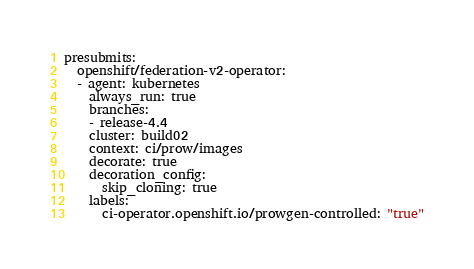<code> <loc_0><loc_0><loc_500><loc_500><_YAML_>presubmits:
  openshift/federation-v2-operator:
  - agent: kubernetes
    always_run: true
    branches:
    - release-4.4
    cluster: build02
    context: ci/prow/images
    decorate: true
    decoration_config:
      skip_cloning: true
    labels:
      ci-operator.openshift.io/prowgen-controlled: "true"</code> 